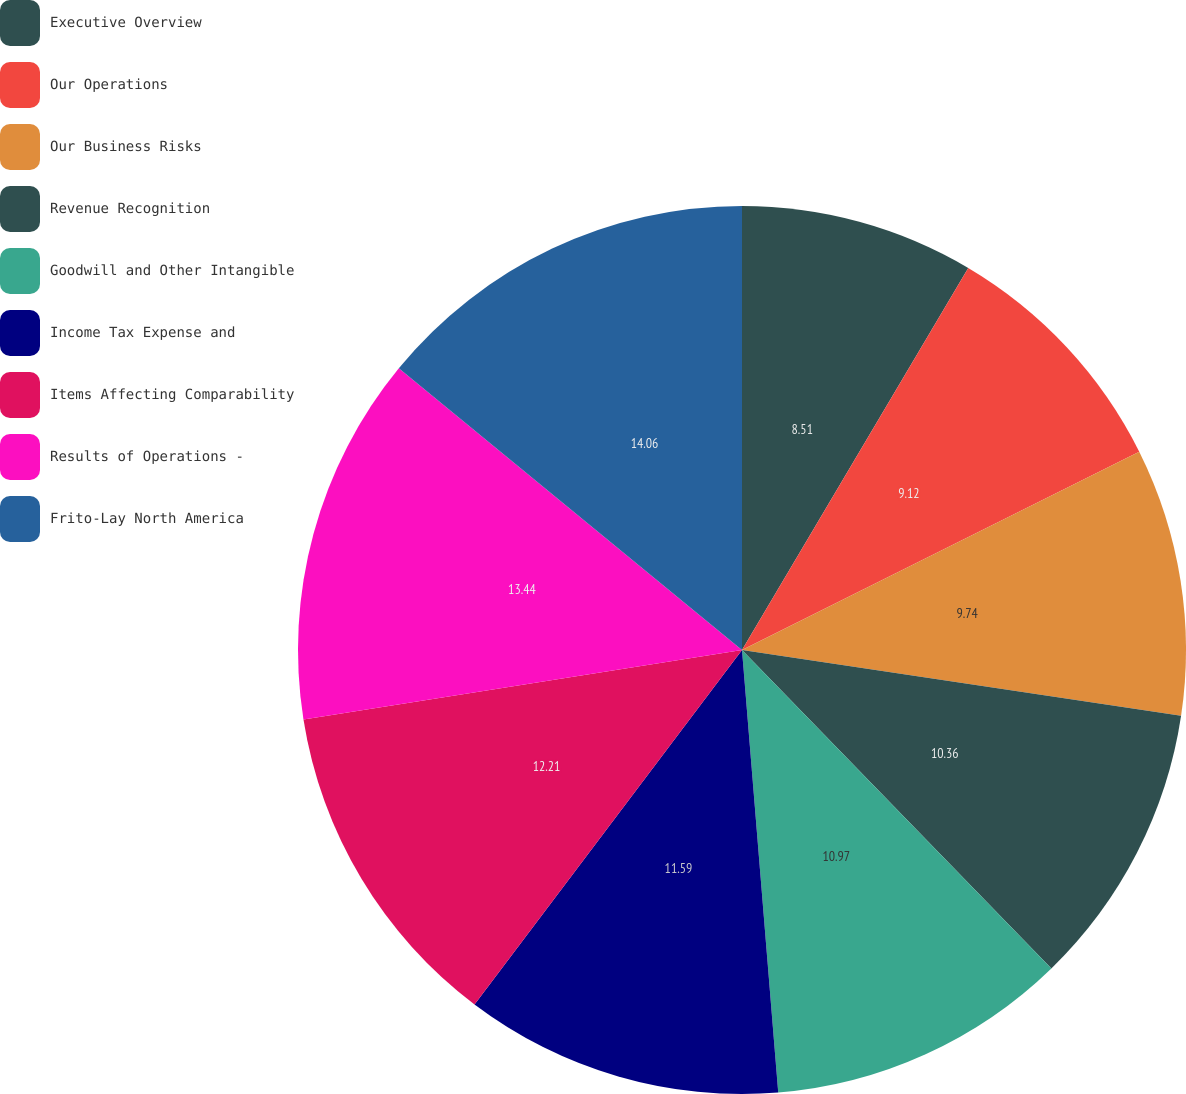Convert chart to OTSL. <chart><loc_0><loc_0><loc_500><loc_500><pie_chart><fcel>Executive Overview<fcel>Our Operations<fcel>Our Business Risks<fcel>Revenue Recognition<fcel>Goodwill and Other Intangible<fcel>Income Tax Expense and<fcel>Items Affecting Comparability<fcel>Results of Operations -<fcel>Frito-Lay North America<nl><fcel>8.51%<fcel>9.12%<fcel>9.74%<fcel>10.36%<fcel>10.97%<fcel>11.59%<fcel>12.21%<fcel>13.44%<fcel>14.06%<nl></chart> 